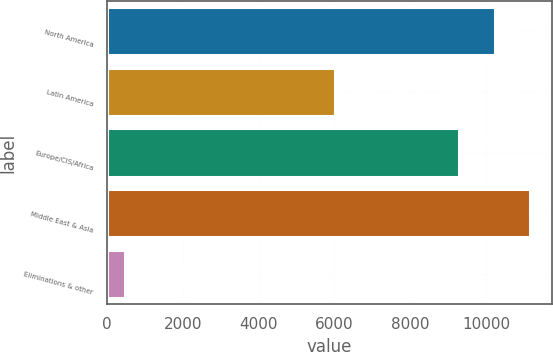<chart> <loc_0><loc_0><loc_500><loc_500><bar_chart><fcel>North America<fcel>Latin America<fcel>Europe/CIS/Africa<fcel>Middle East & Asia<fcel>Eliminations & other<nl><fcel>10227<fcel>6014<fcel>9284<fcel>11170<fcel>468<nl></chart> 